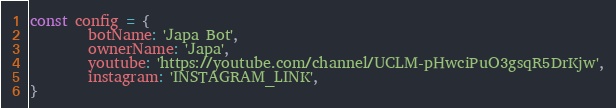Convert code to text. <code><loc_0><loc_0><loc_500><loc_500><_JavaScript_>const config = {
        botName: 'Japa Bot',
        ownerName: 'Japa',
        youtube: 'https://youtube.com/channel/UCLM-pHwciPuO3gsqR5DrKjw',
        instagram: 'INSTAGRAM_LINK',
}
</code> 